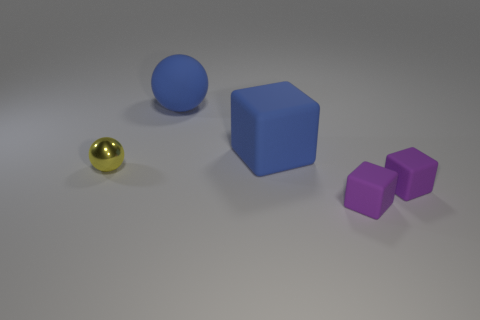Subtract all small purple rubber cubes. How many cubes are left? 1 Add 5 yellow objects. How many objects exist? 10 Subtract all brown cylinders. How many purple blocks are left? 2 Subtract all blocks. How many objects are left? 2 Subtract 1 balls. How many balls are left? 1 Subtract all blue spheres. How many spheres are left? 1 Subtract 0 gray spheres. How many objects are left? 5 Subtract all blue blocks. Subtract all cyan cylinders. How many blocks are left? 2 Subtract all small cubes. Subtract all blue rubber objects. How many objects are left? 1 Add 1 purple objects. How many purple objects are left? 3 